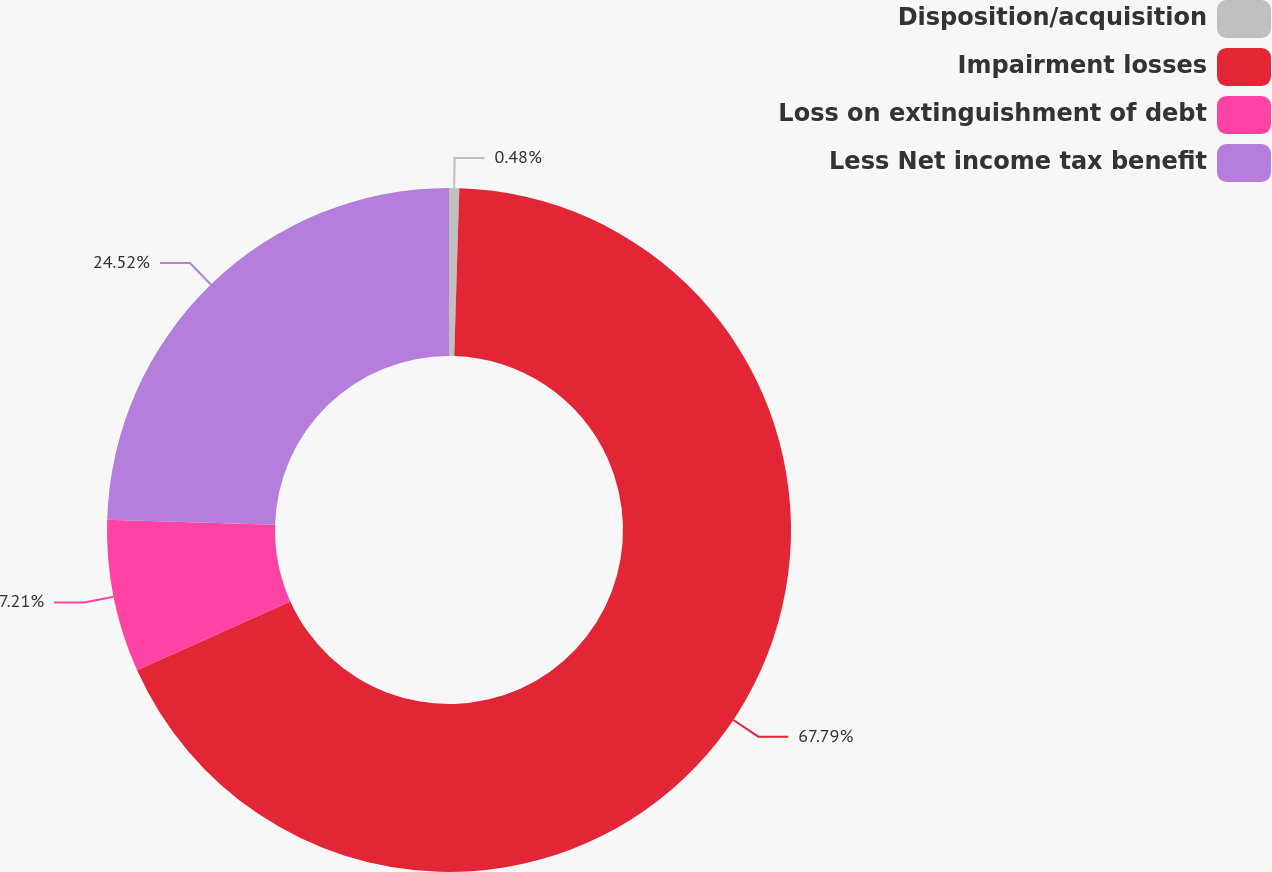Convert chart to OTSL. <chart><loc_0><loc_0><loc_500><loc_500><pie_chart><fcel>Disposition/acquisition<fcel>Impairment losses<fcel>Loss on extinguishment of debt<fcel>Less Net income tax benefit<nl><fcel>0.48%<fcel>67.79%<fcel>7.21%<fcel>24.52%<nl></chart> 